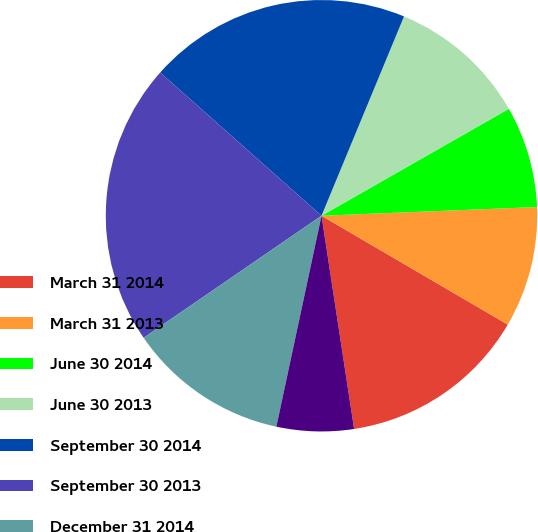Convert chart to OTSL. <chart><loc_0><loc_0><loc_500><loc_500><pie_chart><fcel>March 31 2014<fcel>March 31 2013<fcel>June 30 2014<fcel>June 30 2013<fcel>September 30 2014<fcel>September 30 2013<fcel>December 31 2014<fcel>December 31 2013<nl><fcel>14.17%<fcel>9.06%<fcel>7.61%<fcel>10.5%<fcel>19.69%<fcel>21.13%<fcel>12.07%<fcel>5.77%<nl></chart> 